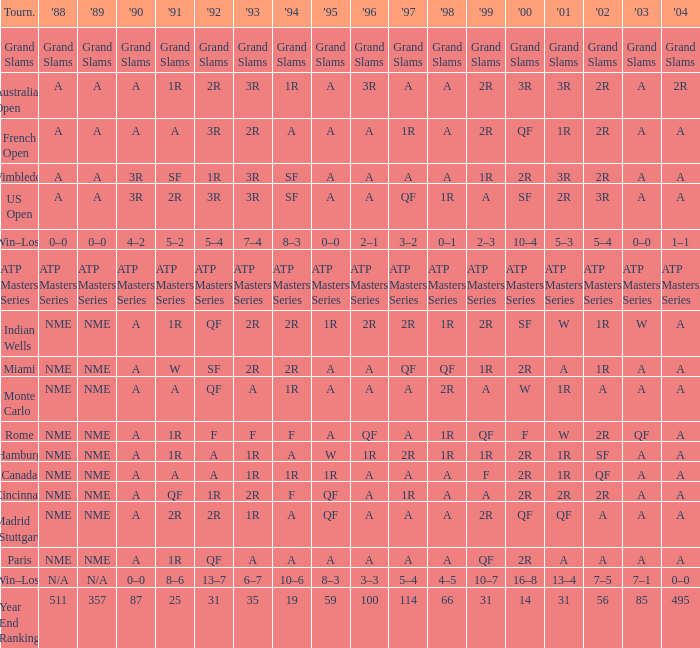What shows for 1992 when 2001 is 1r, 1994 is 1r, and the 2002 is qf? A. 